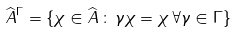<formula> <loc_0><loc_0><loc_500><loc_500>\widehat { A } ^ { \Gamma } = \{ \chi \in \widehat { A } \, \colon \, \gamma \chi = \chi \, \forall \gamma \in \Gamma \}</formula> 